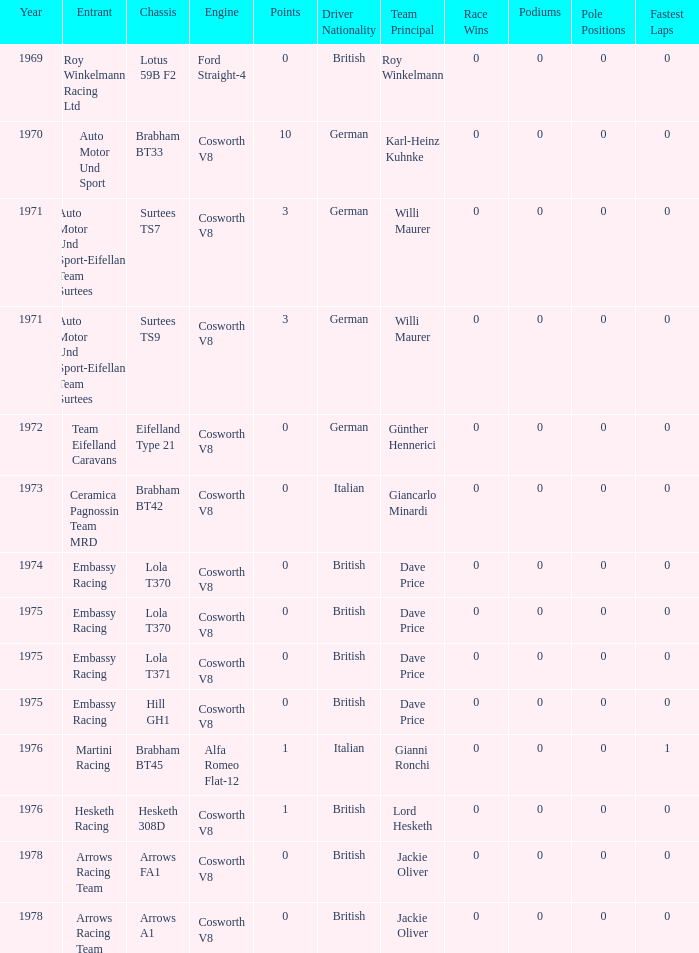In 1970, what entrant had a cosworth v8 engine? Auto Motor Und Sport. 